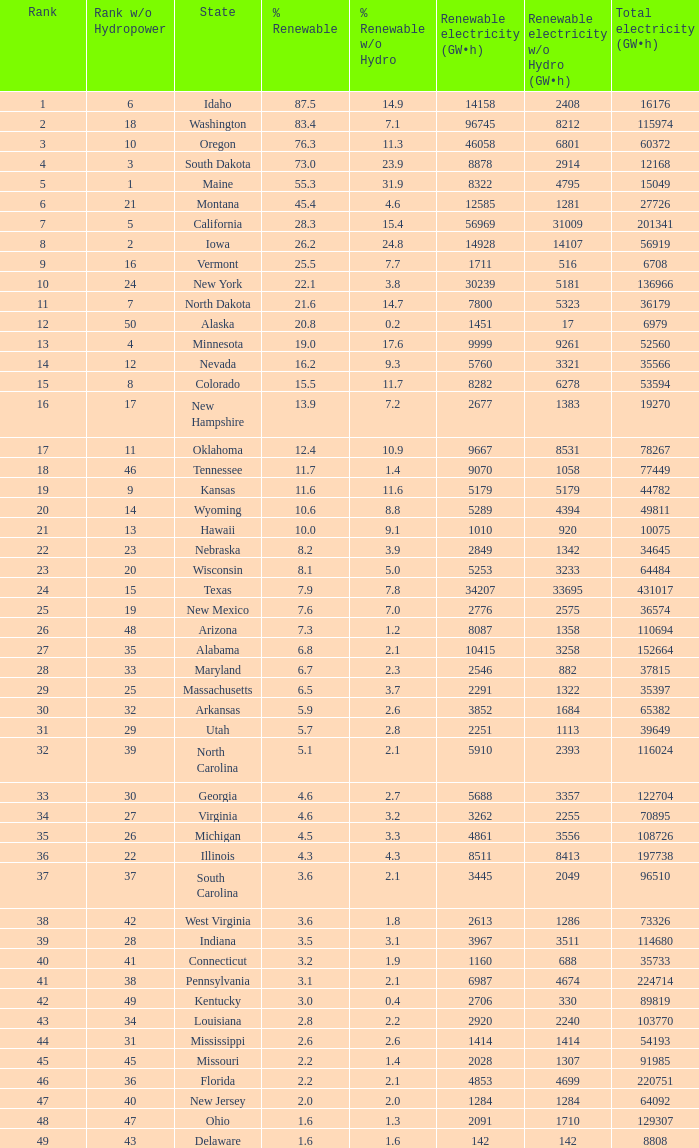What is the share of renewable electricity, excluding hydrogen power, in south dakota? 23.9. 